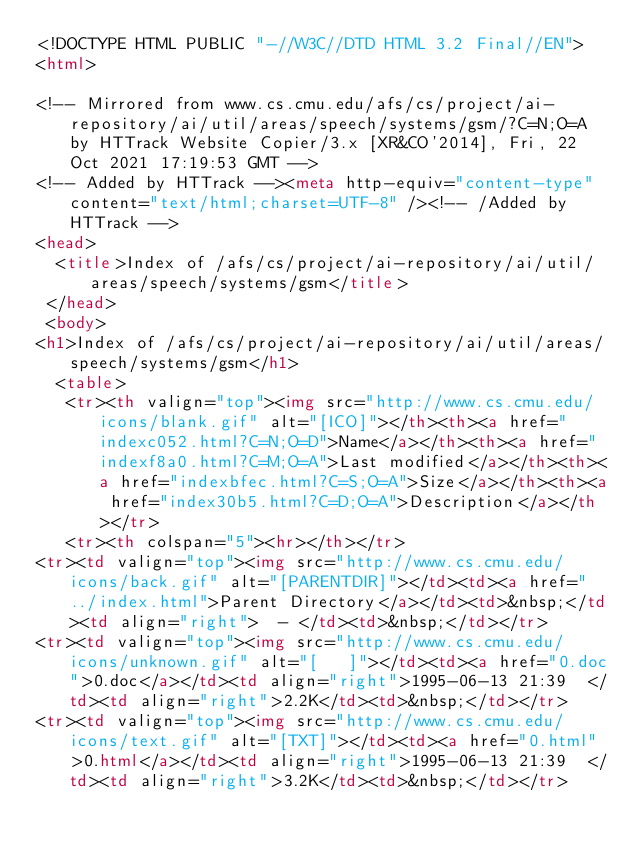<code> <loc_0><loc_0><loc_500><loc_500><_HTML_><!DOCTYPE HTML PUBLIC "-//W3C//DTD HTML 3.2 Final//EN">
<html>
 
<!-- Mirrored from www.cs.cmu.edu/afs/cs/project/ai-repository/ai/util/areas/speech/systems/gsm/?C=N;O=A by HTTrack Website Copier/3.x [XR&CO'2014], Fri, 22 Oct 2021 17:19:53 GMT -->
<!-- Added by HTTrack --><meta http-equiv="content-type" content="text/html;charset=UTF-8" /><!-- /Added by HTTrack -->
<head>
  <title>Index of /afs/cs/project/ai-repository/ai/util/areas/speech/systems/gsm</title>
 </head>
 <body>
<h1>Index of /afs/cs/project/ai-repository/ai/util/areas/speech/systems/gsm</h1>
  <table>
   <tr><th valign="top"><img src="http://www.cs.cmu.edu/icons/blank.gif" alt="[ICO]"></th><th><a href="indexc052.html?C=N;O=D">Name</a></th><th><a href="indexf8a0.html?C=M;O=A">Last modified</a></th><th><a href="indexbfec.html?C=S;O=A">Size</a></th><th><a href="index30b5.html?C=D;O=A">Description</a></th></tr>
   <tr><th colspan="5"><hr></th></tr>
<tr><td valign="top"><img src="http://www.cs.cmu.edu/icons/back.gif" alt="[PARENTDIR]"></td><td><a href="../index.html">Parent Directory</a></td><td>&nbsp;</td><td align="right">  - </td><td>&nbsp;</td></tr>
<tr><td valign="top"><img src="http://www.cs.cmu.edu/icons/unknown.gif" alt="[   ]"></td><td><a href="0.doc">0.doc</a></td><td align="right">1995-06-13 21:39  </td><td align="right">2.2K</td><td>&nbsp;</td></tr>
<tr><td valign="top"><img src="http://www.cs.cmu.edu/icons/text.gif" alt="[TXT]"></td><td><a href="0.html">0.html</a></td><td align="right">1995-06-13 21:39  </td><td align="right">3.2K</td><td>&nbsp;</td></tr></code> 